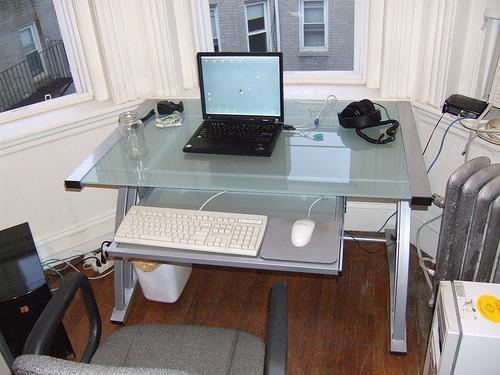How many computers are showing?
Give a very brief answer. 1. 